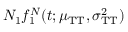<formula> <loc_0><loc_0><loc_500><loc_500>N _ { 1 } f _ { 1 } ^ { N } ( t ; \mu _ { T T } , \sigma _ { T T } ^ { 2 } )</formula> 